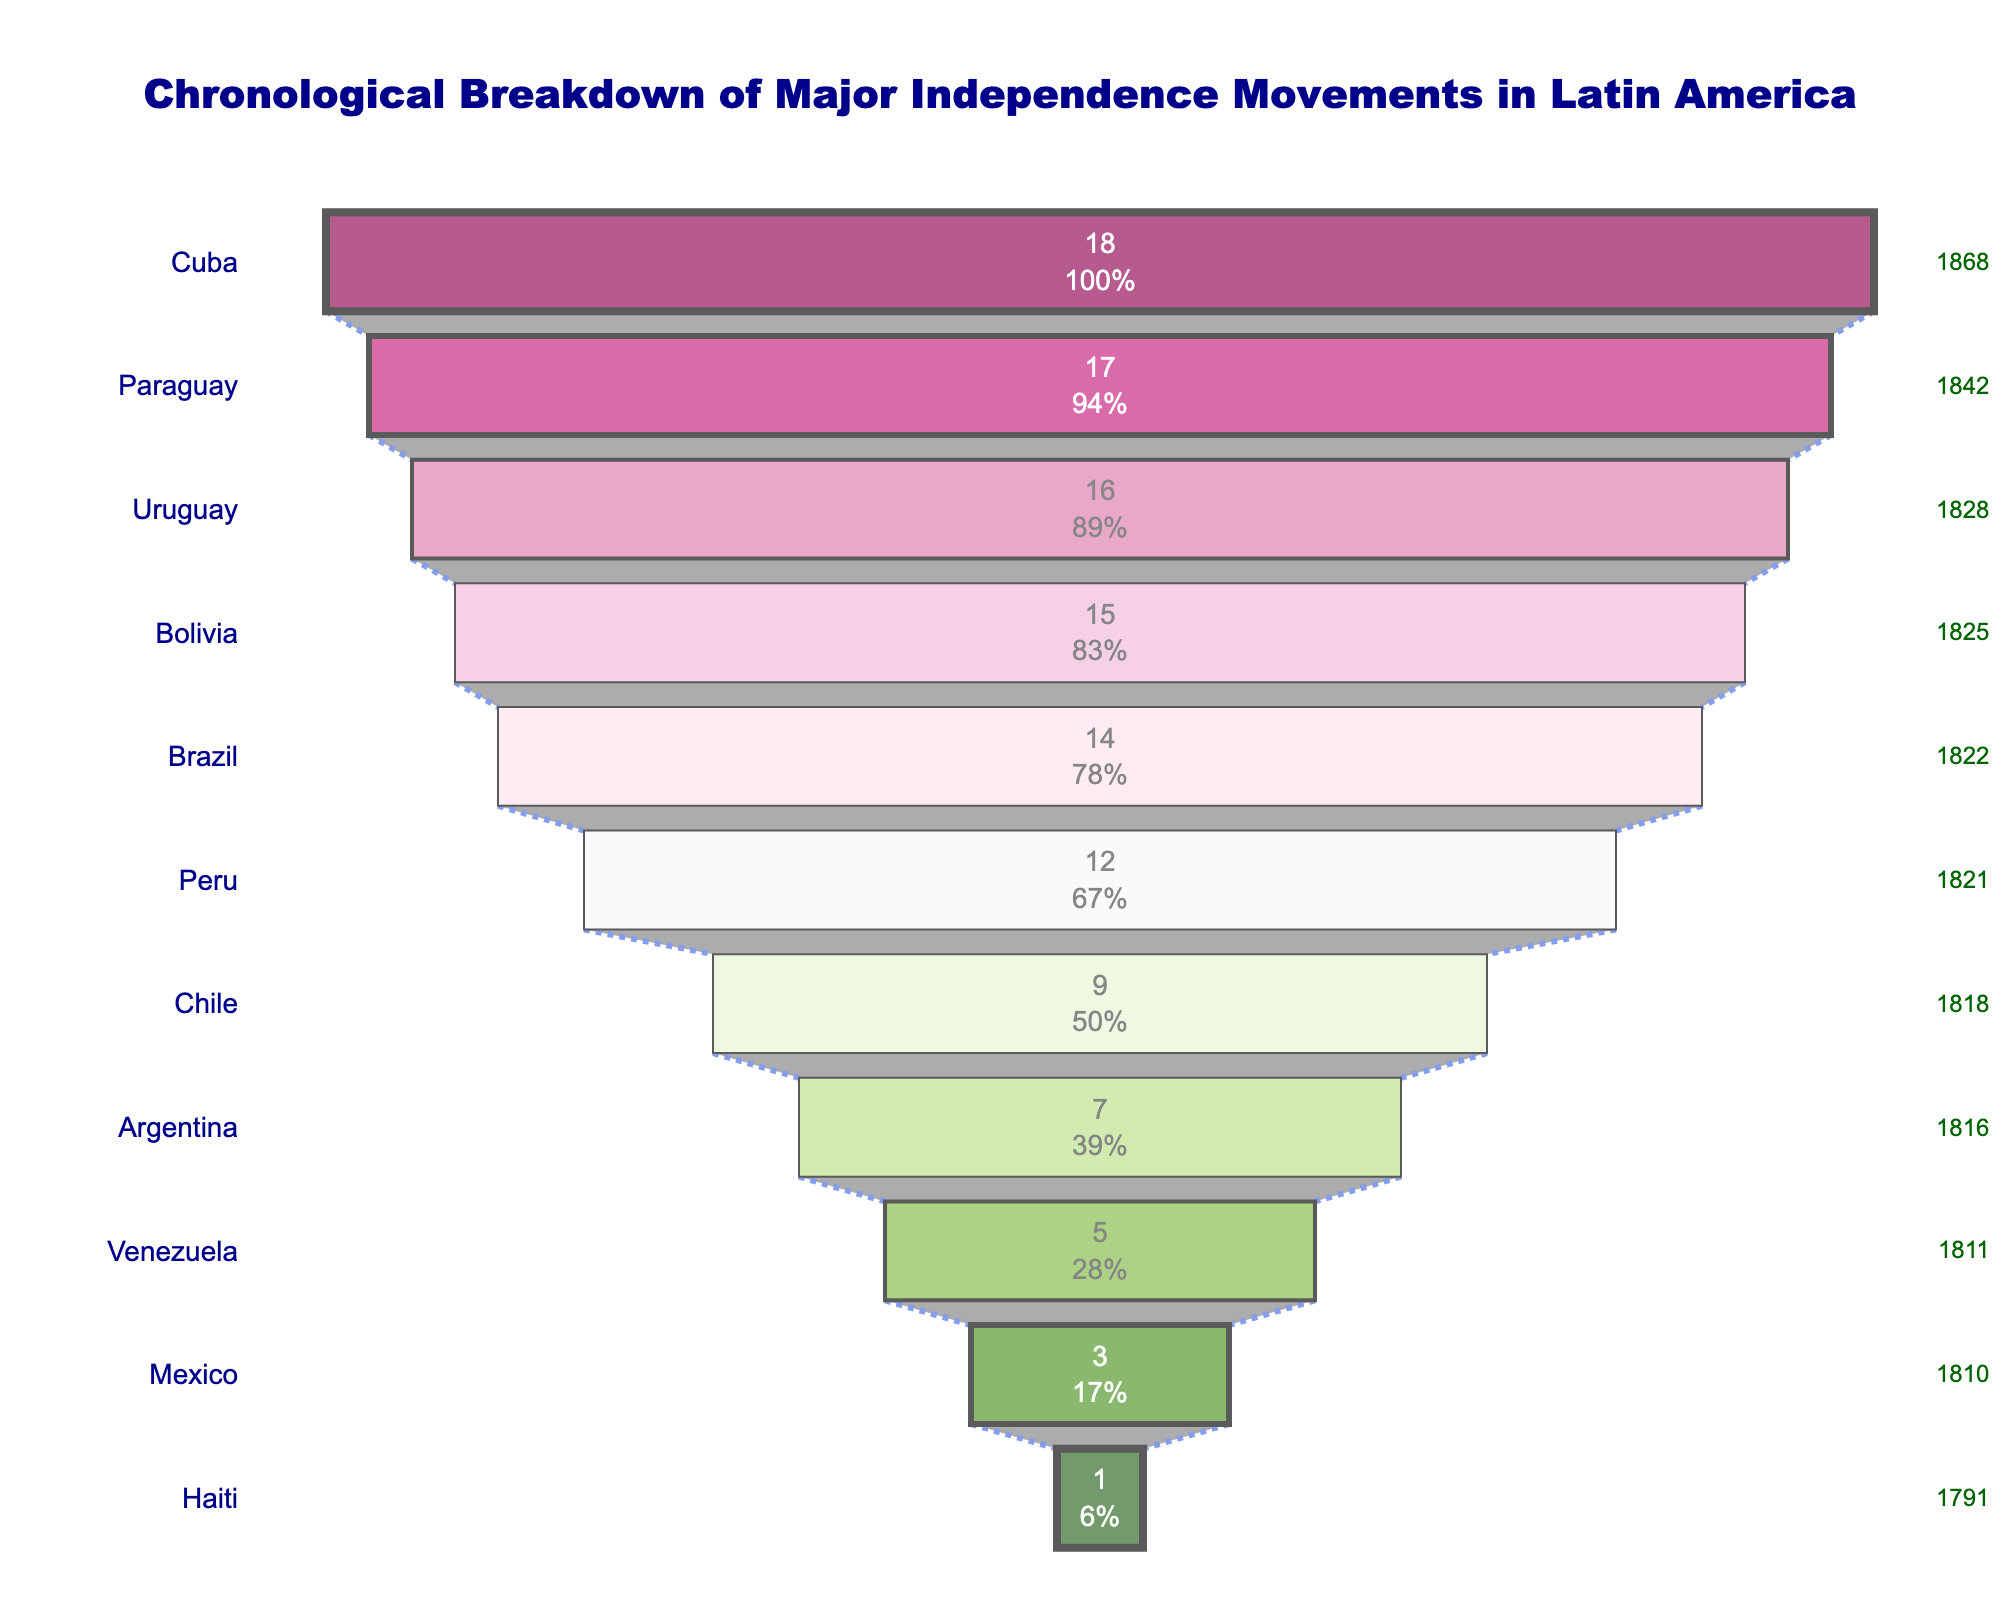What's the title of the figure? The title of the figure is located at the top center of the plot. It is usually displayed in a distinct font size and color.
Answer: Chronological Breakdown of Major Independence Movements in Latin America Which country had its independence movement in 1822? The year annotations are placed along the right side of the figure. By locating 1822, we can see it next to Brazil.
Answer: Brazil How many independence movements are shown in the figure? Each stage of the funnel represents an independent movement, and there are stages listed from Haiti down to Cuba. Counting these stages gives the total number.
Answer: 11 What is the color of the segment representing Venezuela? Each segment of the funnel is colored differently. The third segment from the bottom, representing Venezuela, has a specific shade of color.
Answer: Purple Between which years did most independence movements occur? Most movements occur where the segments are denser. The figure displays varying shades, and the densest cluster can be identified by counting the segments within specific year brackets.
Answer: 1810 to 1842 How many more movements were there by 1828 compared to 1811? Refer to the funnel chart to find the number of movements listed for 1828 (Uruguay) and 1811 (Venezuela). Calculate the difference.
Answer: 16 - 5 = 11 Which country had the first independence movement? The first stage queried at the top of the funnel, marked as Haiti as well as the earliest year 1791.
Answer: Haiti Which two countries had independence movements in the years immediately following 1821? Look at the years 1821 and then identify the following two years in sequence from the list. The countries matching these years are noted.
Answer: Brazil and Bolivia What percentage of independence movements had occurred by the time Chile had its independence? The funnel shows percentages inside each segment. By locating the Chile segment, you can observe the percentage value for movements that had happened by 1818.
Answer: Approximately 52.94% Arrange the countries in order of their independence movement from earliest to latest. Identify each country's segment from top to bottom along with the corresponding year. Then, list them in the order as shown in the funnel.
Answer: Haiti, Mexico, Venezuela, Argentina, Chile, Peru, Brazil, Bolivia, Uruguay, Paraguay, Cuba 